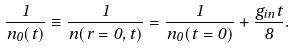<formula> <loc_0><loc_0><loc_500><loc_500>\frac { 1 } { n _ { 0 } ( t ) } \equiv \frac { 1 } { n ( r = 0 , t ) } = \frac { 1 } { n _ { 0 } ( t = 0 ) } + \frac { g _ { i n } t } { 8 } .</formula> 